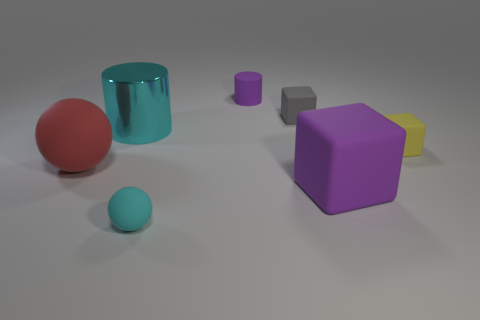Subtract all yellow rubber cubes. How many cubes are left? 2 Add 1 tiny cyan matte blocks. How many objects exist? 8 Subtract all yellow blocks. How many blocks are left? 2 Subtract 1 balls. How many balls are left? 1 Add 3 tiny purple metal cylinders. How many tiny purple metal cylinders exist? 3 Subtract 0 brown cylinders. How many objects are left? 7 Subtract all balls. How many objects are left? 5 Subtract all gray blocks. Subtract all gray cylinders. How many blocks are left? 2 Subtract all green blocks. How many red spheres are left? 1 Subtract all purple cylinders. Subtract all big yellow metallic cylinders. How many objects are left? 6 